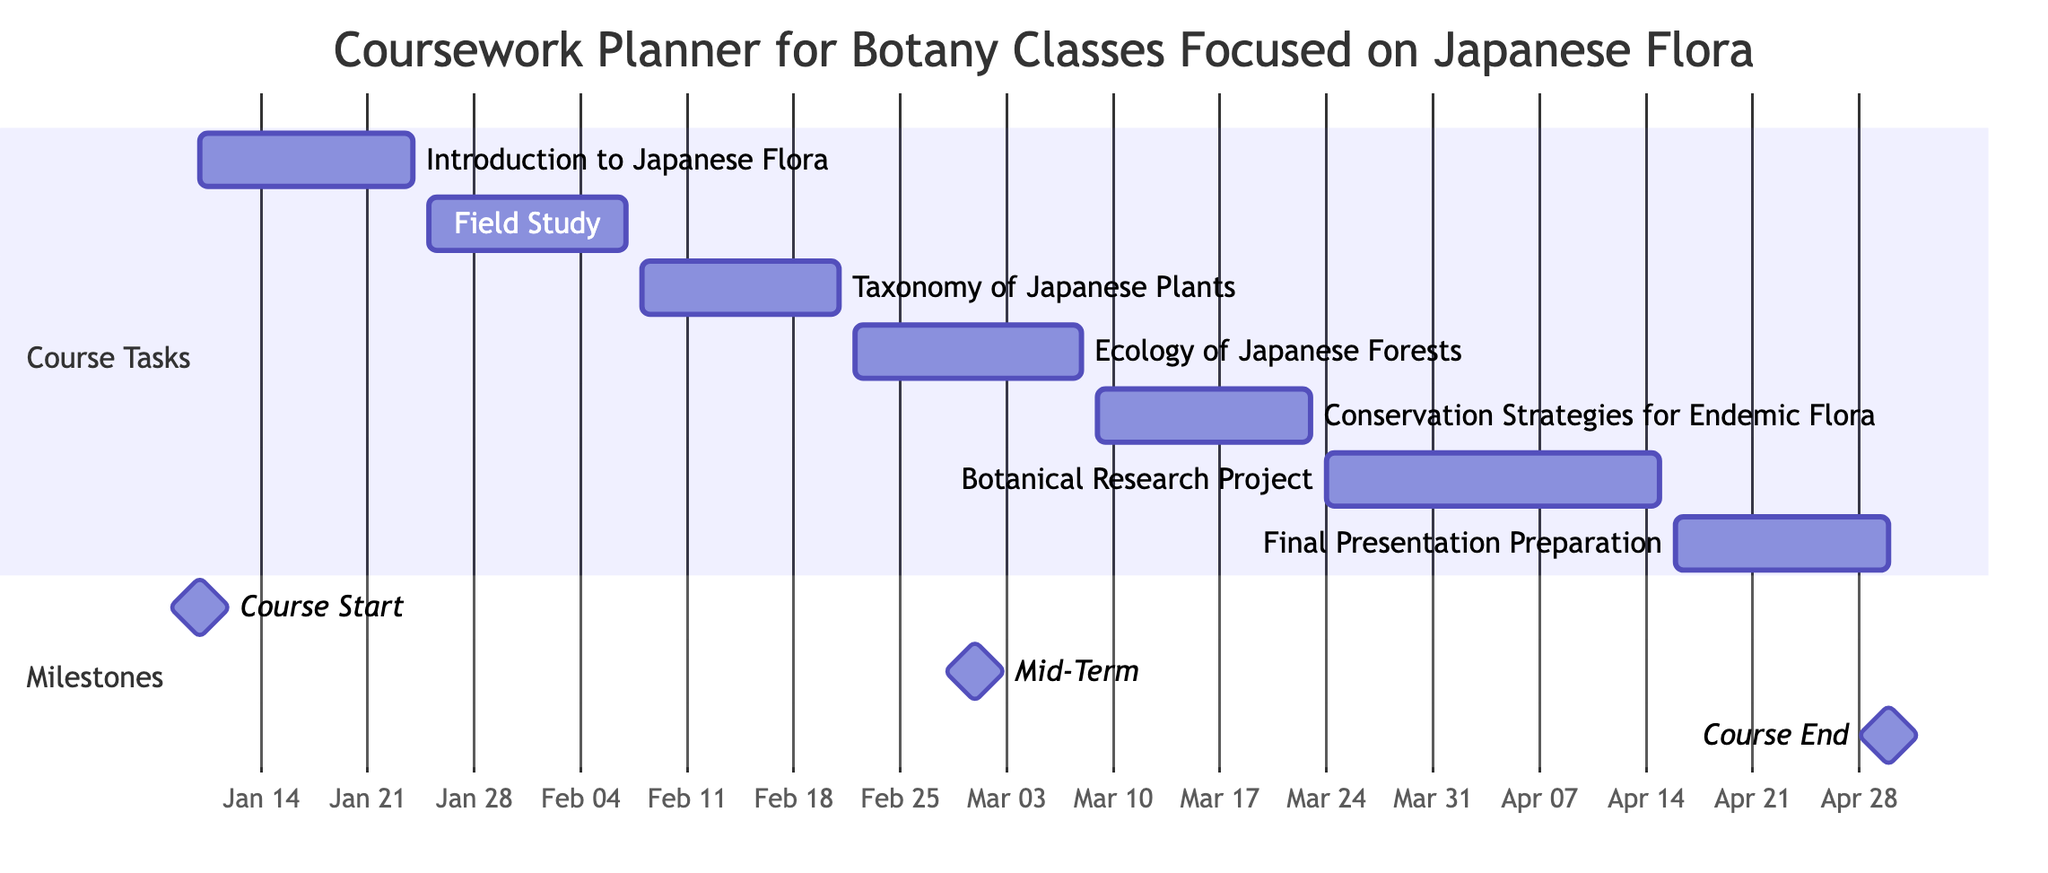What is the duration of the course "Introduction to Japanese Flora"? The task "Introduction to Japanese Flora" starts on January 10, 2024, and ends on January 24, 2024. To find its duration, we calculate the number of days from the start to the end date: January 24 - January 10 + 1 = 15 days.
Answer: 15 days Which task follows "Field Study: Endemic Species Identification"? Looking at the Gantt chart, "Field Study: Endemic Species Identification" ends on February 7, 2024. The subsequent task, which starts immediately after, is "Taxonomy of Japanese Plants," beginning on February 8, 2024.
Answer: Taxonomy of Japanese Plants When does the course end? The course end milestone is shown in the diagram, indicating the course concludes on April 30, 2024.
Answer: April 30, 2024 How many tasks are scheduled between "Ecology of Japanese Forests" and "Conservation Strategies for Endemic Flora"? "Ecology of Japanese Forests" finishes on March 8, 2024, and "Conservation Strategies for Endemic Flora" begins on March 9, 2024. There are no tasks scheduled between these two, hence the count is zero.
Answer: 0 What is the total number of tasks in the Gantt chart? Counting each task listed under the "Course Tasks" section in the diagram, there are seven tasks: "Introduction to Japanese Flora," "Field Study: Endemic Species Identification," "Taxonomy of Japanese Plants," "Ecology of Japanese Forests," "Conservation Strategies for Endemic Flora," "Botanical Research Project: Focus on Flora of Shikoku," and "Final Presentation Preparation." Thus, the total number is seven.
Answer: 7 What is the start date of the "Botanical Research Project: Focus on Flora of Shikoku"? The "Botanical Research Project: Focus on Flora of Shikoku" starts on March 24, 2024, as indicated directly on the Gantt chart.
Answer: March 24, 2024 Which milestone marks the midpoint of the coursework? The diagram indicates a milestone labeled "Mid-Term," and it is scheduled for March 1, 2024, which serves as the midpoint of the coursework timeline.
Answer: March 1, 2024 What is the earliest task scheduled? The earliest task depicted in the Gantt chart is "Introduction to Japanese Flora," which begins on January 10, 2024.
Answer: Introduction to Japanese Flora 